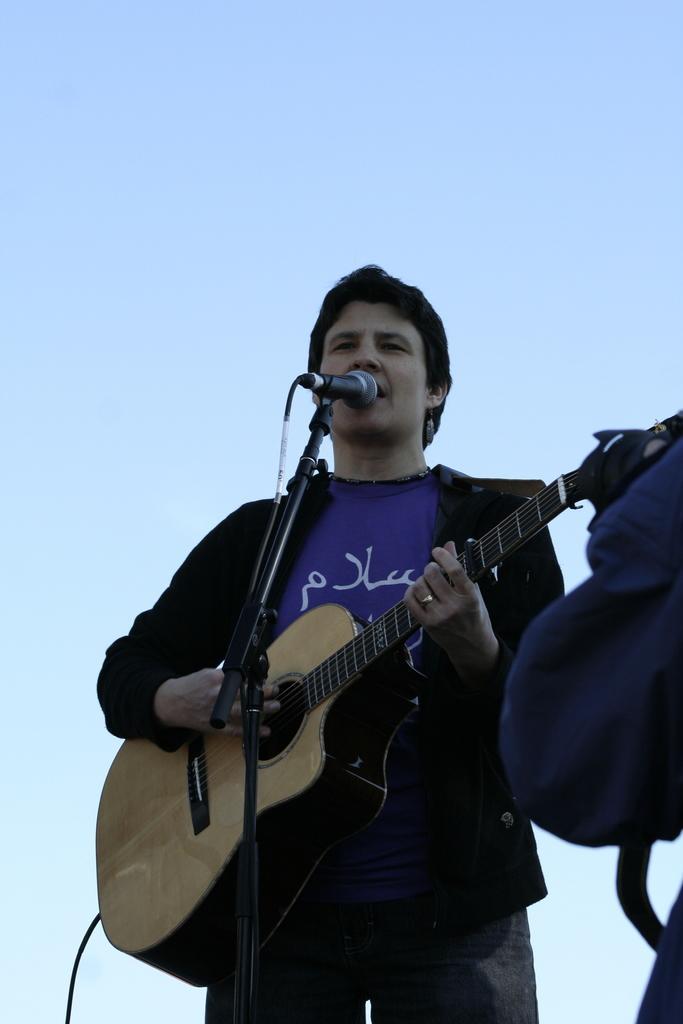In one or two sentences, can you explain what this image depicts? In the picture a person is standing in front of a microphone and singing he is also playing guitar there is a clear sky. 